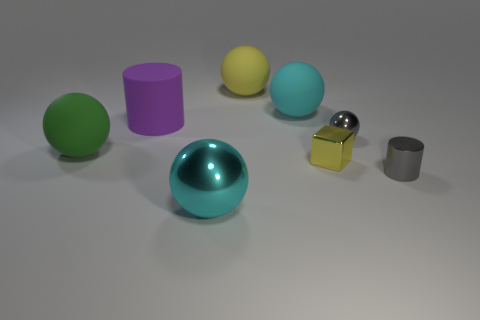Subtract all tiny shiny spheres. How many spheres are left? 4 Subtract 2 balls. How many balls are left? 3 Subtract all blue blocks. How many cyan spheres are left? 2 Add 1 yellow metallic objects. How many objects exist? 9 Subtract all yellow spheres. How many spheres are left? 4 Subtract all yellow balls. Subtract all red cubes. How many balls are left? 4 Subtract 0 yellow cylinders. How many objects are left? 8 Subtract all blocks. How many objects are left? 7 Subtract all large gray shiny cubes. Subtract all small shiny objects. How many objects are left? 5 Add 8 cyan spheres. How many cyan spheres are left? 10 